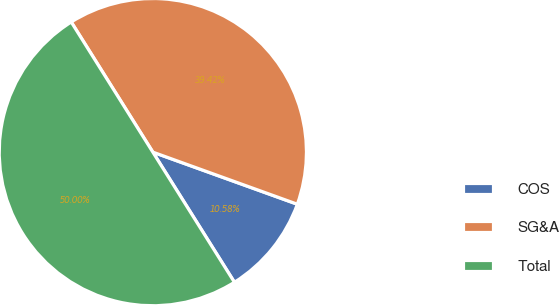Convert chart. <chart><loc_0><loc_0><loc_500><loc_500><pie_chart><fcel>COS<fcel>SG&A<fcel>Total<nl><fcel>10.58%<fcel>39.42%<fcel>50.0%<nl></chart> 